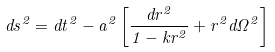<formula> <loc_0><loc_0><loc_500><loc_500>d s ^ { 2 } = d t ^ { 2 } - a ^ { 2 } \left [ \frac { d r ^ { 2 } } { 1 - k r ^ { 2 } } + r ^ { 2 } d \Omega ^ { 2 } \right ]</formula> 